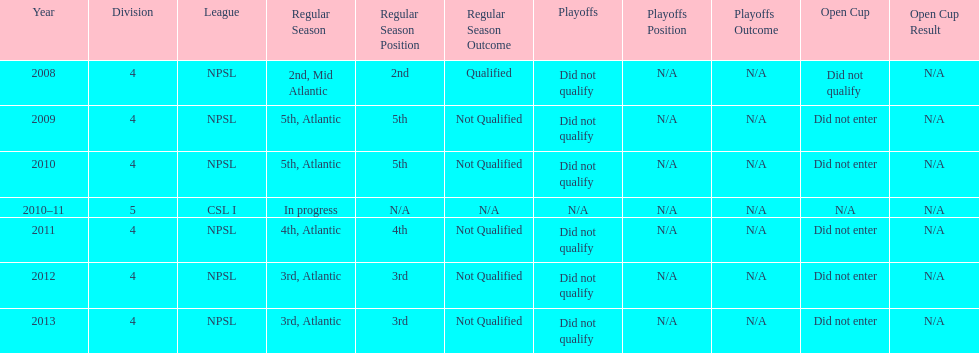What is the lowest place they came in 5th. 